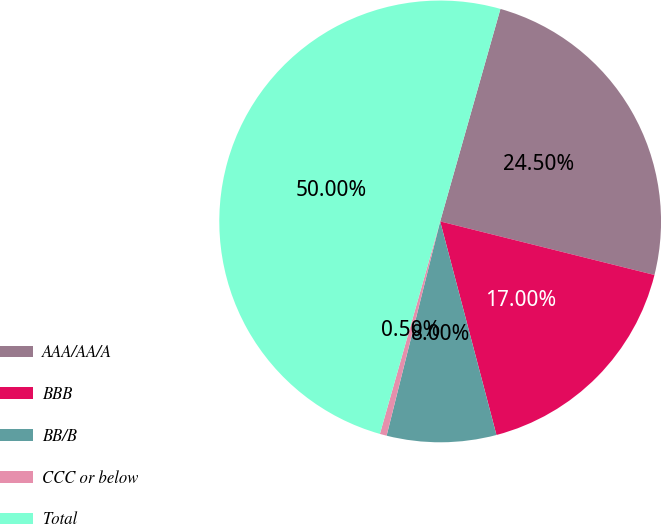Convert chart. <chart><loc_0><loc_0><loc_500><loc_500><pie_chart><fcel>AAA/AA/A<fcel>BBB<fcel>BB/B<fcel>CCC or below<fcel>Total<nl><fcel>24.5%<fcel>17.0%<fcel>8.0%<fcel>0.5%<fcel>50.0%<nl></chart> 